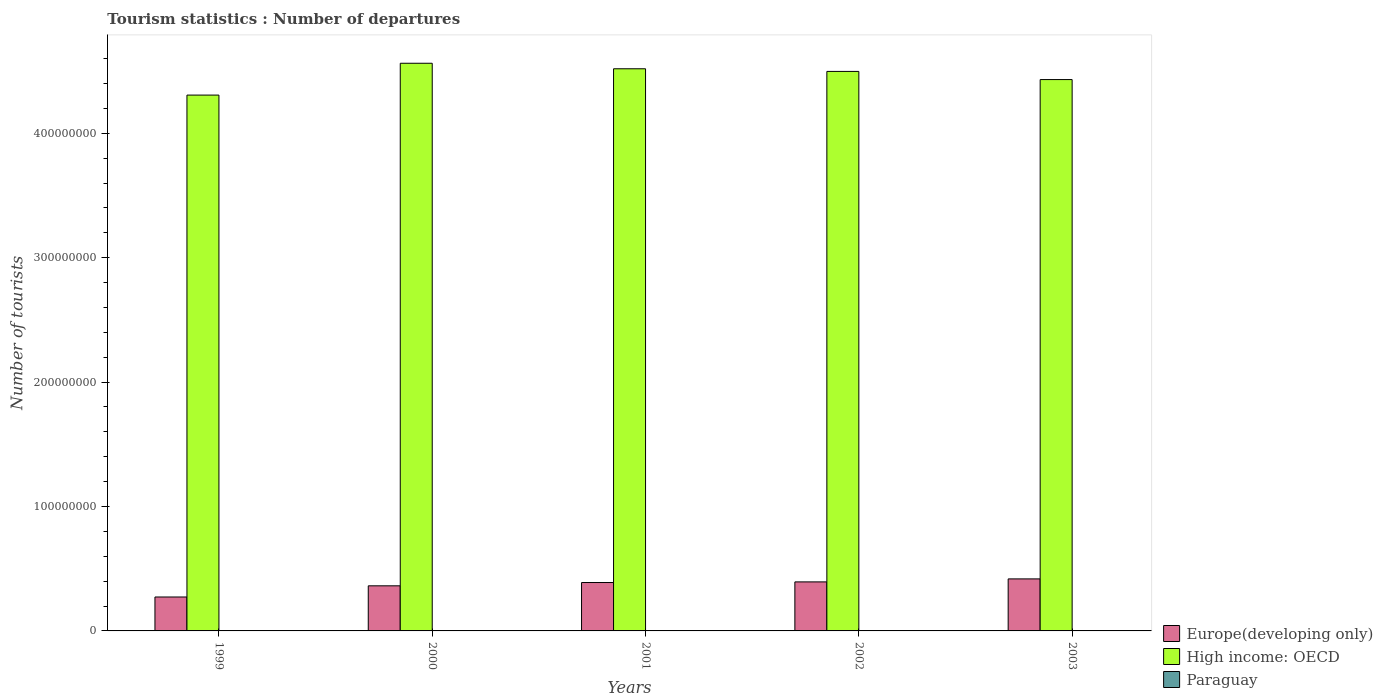Are the number of bars on each tick of the X-axis equal?
Provide a short and direct response. Yes. What is the number of tourist departures in Europe(developing only) in 2002?
Your response must be concise. 3.94e+07. Across all years, what is the maximum number of tourist departures in High income: OECD?
Offer a terse response. 4.56e+08. Across all years, what is the minimum number of tourist departures in High income: OECD?
Offer a very short reply. 4.31e+08. What is the total number of tourist departures in High income: OECD in the graph?
Offer a very short reply. 2.23e+09. What is the difference between the number of tourist departures in Paraguay in 2000 and that in 2002?
Keep it short and to the point. 3.40e+04. What is the difference between the number of tourist departures in Paraguay in 2001 and the number of tourist departures in High income: OECD in 1999?
Offer a very short reply. -4.31e+08. What is the average number of tourist departures in High income: OECD per year?
Provide a short and direct response. 4.46e+08. In the year 2000, what is the difference between the number of tourist departures in Paraguay and number of tourist departures in High income: OECD?
Offer a very short reply. -4.56e+08. In how many years, is the number of tourist departures in Paraguay greater than 380000000?
Your answer should be very brief. 0. What is the ratio of the number of tourist departures in High income: OECD in 2002 to that in 2003?
Provide a succinct answer. 1.01. Is the number of tourist departures in Paraguay in 2002 less than that in 2003?
Your response must be concise. Yes. Is the difference between the number of tourist departures in Paraguay in 2000 and 2002 greater than the difference between the number of tourist departures in High income: OECD in 2000 and 2002?
Provide a short and direct response. No. What is the difference between the highest and the second highest number of tourist departures in Paraguay?
Offer a terse response. 1.06e+05. What is the difference between the highest and the lowest number of tourist departures in High income: OECD?
Your answer should be compact. 2.56e+07. In how many years, is the number of tourist departures in High income: OECD greater than the average number of tourist departures in High income: OECD taken over all years?
Make the answer very short. 3. Is the sum of the number of tourist departures in Paraguay in 2000 and 2001 greater than the maximum number of tourist departures in Europe(developing only) across all years?
Give a very brief answer. No. What does the 1st bar from the left in 2000 represents?
Make the answer very short. Europe(developing only). What does the 3rd bar from the right in 1999 represents?
Your answer should be very brief. Europe(developing only). How many years are there in the graph?
Provide a succinct answer. 5. Are the values on the major ticks of Y-axis written in scientific E-notation?
Your answer should be very brief. No. Does the graph contain any zero values?
Offer a very short reply. No. Where does the legend appear in the graph?
Provide a short and direct response. Bottom right. What is the title of the graph?
Give a very brief answer. Tourism statistics : Number of departures. What is the label or title of the X-axis?
Provide a short and direct response. Years. What is the label or title of the Y-axis?
Provide a short and direct response. Number of tourists. What is the Number of tourists in Europe(developing only) in 1999?
Offer a very short reply. 2.73e+07. What is the Number of tourists of High income: OECD in 1999?
Make the answer very short. 4.31e+08. What is the Number of tourists of Paraguay in 1999?
Keep it short and to the point. 2.81e+05. What is the Number of tourists in Europe(developing only) in 2000?
Ensure brevity in your answer.  3.63e+07. What is the Number of tourists of High income: OECD in 2000?
Your response must be concise. 4.56e+08. What is the Number of tourists in Paraguay in 2000?
Keep it short and to the point. 1.75e+05. What is the Number of tourists in Europe(developing only) in 2001?
Your answer should be very brief. 3.89e+07. What is the Number of tourists of High income: OECD in 2001?
Your response must be concise. 4.52e+08. What is the Number of tourists in Paraguay in 2001?
Ensure brevity in your answer.  1.57e+05. What is the Number of tourists of Europe(developing only) in 2002?
Your answer should be very brief. 3.94e+07. What is the Number of tourists of High income: OECD in 2002?
Keep it short and to the point. 4.50e+08. What is the Number of tourists in Paraguay in 2002?
Give a very brief answer. 1.41e+05. What is the Number of tourists in Europe(developing only) in 2003?
Provide a succinct answer. 4.18e+07. What is the Number of tourists of High income: OECD in 2003?
Make the answer very short. 4.43e+08. What is the Number of tourists of Paraguay in 2003?
Make the answer very short. 1.53e+05. Across all years, what is the maximum Number of tourists of Europe(developing only)?
Ensure brevity in your answer.  4.18e+07. Across all years, what is the maximum Number of tourists in High income: OECD?
Provide a short and direct response. 4.56e+08. Across all years, what is the maximum Number of tourists in Paraguay?
Your answer should be very brief. 2.81e+05. Across all years, what is the minimum Number of tourists in Europe(developing only)?
Keep it short and to the point. 2.73e+07. Across all years, what is the minimum Number of tourists of High income: OECD?
Keep it short and to the point. 4.31e+08. Across all years, what is the minimum Number of tourists of Paraguay?
Make the answer very short. 1.41e+05. What is the total Number of tourists of Europe(developing only) in the graph?
Offer a terse response. 1.84e+08. What is the total Number of tourists in High income: OECD in the graph?
Offer a very short reply. 2.23e+09. What is the total Number of tourists of Paraguay in the graph?
Give a very brief answer. 9.07e+05. What is the difference between the Number of tourists of Europe(developing only) in 1999 and that in 2000?
Make the answer very short. -8.98e+06. What is the difference between the Number of tourists of High income: OECD in 1999 and that in 2000?
Keep it short and to the point. -2.56e+07. What is the difference between the Number of tourists of Paraguay in 1999 and that in 2000?
Offer a terse response. 1.06e+05. What is the difference between the Number of tourists of Europe(developing only) in 1999 and that in 2001?
Provide a short and direct response. -1.16e+07. What is the difference between the Number of tourists of High income: OECD in 1999 and that in 2001?
Your response must be concise. -2.11e+07. What is the difference between the Number of tourists in Paraguay in 1999 and that in 2001?
Provide a short and direct response. 1.24e+05. What is the difference between the Number of tourists of Europe(developing only) in 1999 and that in 2002?
Offer a very short reply. -1.21e+07. What is the difference between the Number of tourists in High income: OECD in 1999 and that in 2002?
Your answer should be very brief. -1.90e+07. What is the difference between the Number of tourists in Paraguay in 1999 and that in 2002?
Make the answer very short. 1.40e+05. What is the difference between the Number of tourists of Europe(developing only) in 1999 and that in 2003?
Give a very brief answer. -1.45e+07. What is the difference between the Number of tourists in High income: OECD in 1999 and that in 2003?
Ensure brevity in your answer.  -1.25e+07. What is the difference between the Number of tourists of Paraguay in 1999 and that in 2003?
Keep it short and to the point. 1.28e+05. What is the difference between the Number of tourists of Europe(developing only) in 2000 and that in 2001?
Give a very brief answer. -2.65e+06. What is the difference between the Number of tourists of High income: OECD in 2000 and that in 2001?
Offer a very short reply. 4.44e+06. What is the difference between the Number of tourists of Paraguay in 2000 and that in 2001?
Your response must be concise. 1.80e+04. What is the difference between the Number of tourists of Europe(developing only) in 2000 and that in 2002?
Ensure brevity in your answer.  -3.16e+06. What is the difference between the Number of tourists in High income: OECD in 2000 and that in 2002?
Provide a short and direct response. 6.56e+06. What is the difference between the Number of tourists in Paraguay in 2000 and that in 2002?
Offer a very short reply. 3.40e+04. What is the difference between the Number of tourists in Europe(developing only) in 2000 and that in 2003?
Keep it short and to the point. -5.57e+06. What is the difference between the Number of tourists of High income: OECD in 2000 and that in 2003?
Ensure brevity in your answer.  1.31e+07. What is the difference between the Number of tourists in Paraguay in 2000 and that in 2003?
Offer a very short reply. 2.20e+04. What is the difference between the Number of tourists of Europe(developing only) in 2001 and that in 2002?
Offer a terse response. -5.12e+05. What is the difference between the Number of tourists in High income: OECD in 2001 and that in 2002?
Provide a succinct answer. 2.12e+06. What is the difference between the Number of tourists in Paraguay in 2001 and that in 2002?
Keep it short and to the point. 1.60e+04. What is the difference between the Number of tourists of Europe(developing only) in 2001 and that in 2003?
Give a very brief answer. -2.92e+06. What is the difference between the Number of tourists in High income: OECD in 2001 and that in 2003?
Keep it short and to the point. 8.67e+06. What is the difference between the Number of tourists of Paraguay in 2001 and that in 2003?
Your answer should be very brief. 4000. What is the difference between the Number of tourists in Europe(developing only) in 2002 and that in 2003?
Your response must be concise. -2.41e+06. What is the difference between the Number of tourists of High income: OECD in 2002 and that in 2003?
Offer a terse response. 6.55e+06. What is the difference between the Number of tourists of Paraguay in 2002 and that in 2003?
Provide a short and direct response. -1.20e+04. What is the difference between the Number of tourists in Europe(developing only) in 1999 and the Number of tourists in High income: OECD in 2000?
Provide a short and direct response. -4.29e+08. What is the difference between the Number of tourists in Europe(developing only) in 1999 and the Number of tourists in Paraguay in 2000?
Make the answer very short. 2.71e+07. What is the difference between the Number of tourists of High income: OECD in 1999 and the Number of tourists of Paraguay in 2000?
Make the answer very short. 4.31e+08. What is the difference between the Number of tourists in Europe(developing only) in 1999 and the Number of tourists in High income: OECD in 2001?
Offer a very short reply. -4.25e+08. What is the difference between the Number of tourists of Europe(developing only) in 1999 and the Number of tourists of Paraguay in 2001?
Make the answer very short. 2.71e+07. What is the difference between the Number of tourists in High income: OECD in 1999 and the Number of tourists in Paraguay in 2001?
Your answer should be very brief. 4.31e+08. What is the difference between the Number of tourists of Europe(developing only) in 1999 and the Number of tourists of High income: OECD in 2002?
Your response must be concise. -4.22e+08. What is the difference between the Number of tourists in Europe(developing only) in 1999 and the Number of tourists in Paraguay in 2002?
Your response must be concise. 2.71e+07. What is the difference between the Number of tourists in High income: OECD in 1999 and the Number of tourists in Paraguay in 2002?
Give a very brief answer. 4.31e+08. What is the difference between the Number of tourists in Europe(developing only) in 1999 and the Number of tourists in High income: OECD in 2003?
Keep it short and to the point. -4.16e+08. What is the difference between the Number of tourists in Europe(developing only) in 1999 and the Number of tourists in Paraguay in 2003?
Your response must be concise. 2.71e+07. What is the difference between the Number of tourists of High income: OECD in 1999 and the Number of tourists of Paraguay in 2003?
Your answer should be compact. 4.31e+08. What is the difference between the Number of tourists in Europe(developing only) in 2000 and the Number of tourists in High income: OECD in 2001?
Your answer should be compact. -4.16e+08. What is the difference between the Number of tourists of Europe(developing only) in 2000 and the Number of tourists of Paraguay in 2001?
Offer a terse response. 3.61e+07. What is the difference between the Number of tourists of High income: OECD in 2000 and the Number of tourists of Paraguay in 2001?
Give a very brief answer. 4.56e+08. What is the difference between the Number of tourists in Europe(developing only) in 2000 and the Number of tourists in High income: OECD in 2002?
Make the answer very short. -4.13e+08. What is the difference between the Number of tourists of Europe(developing only) in 2000 and the Number of tourists of Paraguay in 2002?
Give a very brief answer. 3.61e+07. What is the difference between the Number of tourists in High income: OECD in 2000 and the Number of tourists in Paraguay in 2002?
Provide a short and direct response. 4.56e+08. What is the difference between the Number of tourists of Europe(developing only) in 2000 and the Number of tourists of High income: OECD in 2003?
Offer a very short reply. -4.07e+08. What is the difference between the Number of tourists of Europe(developing only) in 2000 and the Number of tourists of Paraguay in 2003?
Give a very brief answer. 3.61e+07. What is the difference between the Number of tourists of High income: OECD in 2000 and the Number of tourists of Paraguay in 2003?
Offer a very short reply. 4.56e+08. What is the difference between the Number of tourists in Europe(developing only) in 2001 and the Number of tourists in High income: OECD in 2002?
Offer a terse response. -4.11e+08. What is the difference between the Number of tourists of Europe(developing only) in 2001 and the Number of tourists of Paraguay in 2002?
Provide a succinct answer. 3.88e+07. What is the difference between the Number of tourists in High income: OECD in 2001 and the Number of tourists in Paraguay in 2002?
Ensure brevity in your answer.  4.52e+08. What is the difference between the Number of tourists of Europe(developing only) in 2001 and the Number of tourists of High income: OECD in 2003?
Give a very brief answer. -4.04e+08. What is the difference between the Number of tourists of Europe(developing only) in 2001 and the Number of tourists of Paraguay in 2003?
Offer a terse response. 3.87e+07. What is the difference between the Number of tourists in High income: OECD in 2001 and the Number of tourists in Paraguay in 2003?
Keep it short and to the point. 4.52e+08. What is the difference between the Number of tourists in Europe(developing only) in 2002 and the Number of tourists in High income: OECD in 2003?
Offer a terse response. -4.04e+08. What is the difference between the Number of tourists in Europe(developing only) in 2002 and the Number of tourists in Paraguay in 2003?
Offer a very short reply. 3.93e+07. What is the difference between the Number of tourists of High income: OECD in 2002 and the Number of tourists of Paraguay in 2003?
Your answer should be very brief. 4.50e+08. What is the average Number of tourists of Europe(developing only) per year?
Your answer should be compact. 3.67e+07. What is the average Number of tourists of High income: OECD per year?
Make the answer very short. 4.46e+08. What is the average Number of tourists in Paraguay per year?
Keep it short and to the point. 1.81e+05. In the year 1999, what is the difference between the Number of tourists of Europe(developing only) and Number of tourists of High income: OECD?
Offer a very short reply. -4.03e+08. In the year 1999, what is the difference between the Number of tourists in Europe(developing only) and Number of tourists in Paraguay?
Make the answer very short. 2.70e+07. In the year 1999, what is the difference between the Number of tourists in High income: OECD and Number of tourists in Paraguay?
Your answer should be very brief. 4.30e+08. In the year 2000, what is the difference between the Number of tourists of Europe(developing only) and Number of tourists of High income: OECD?
Provide a short and direct response. -4.20e+08. In the year 2000, what is the difference between the Number of tourists of Europe(developing only) and Number of tourists of Paraguay?
Provide a succinct answer. 3.61e+07. In the year 2000, what is the difference between the Number of tourists in High income: OECD and Number of tourists in Paraguay?
Provide a succinct answer. 4.56e+08. In the year 2001, what is the difference between the Number of tourists of Europe(developing only) and Number of tourists of High income: OECD?
Provide a short and direct response. -4.13e+08. In the year 2001, what is the difference between the Number of tourists in Europe(developing only) and Number of tourists in Paraguay?
Make the answer very short. 3.87e+07. In the year 2001, what is the difference between the Number of tourists of High income: OECD and Number of tourists of Paraguay?
Give a very brief answer. 4.52e+08. In the year 2002, what is the difference between the Number of tourists in Europe(developing only) and Number of tourists in High income: OECD?
Provide a succinct answer. -4.10e+08. In the year 2002, what is the difference between the Number of tourists in Europe(developing only) and Number of tourists in Paraguay?
Your answer should be very brief. 3.93e+07. In the year 2002, what is the difference between the Number of tourists of High income: OECD and Number of tourists of Paraguay?
Your answer should be compact. 4.50e+08. In the year 2003, what is the difference between the Number of tourists in Europe(developing only) and Number of tourists in High income: OECD?
Provide a short and direct response. -4.01e+08. In the year 2003, what is the difference between the Number of tourists in Europe(developing only) and Number of tourists in Paraguay?
Keep it short and to the point. 4.17e+07. In the year 2003, what is the difference between the Number of tourists in High income: OECD and Number of tourists in Paraguay?
Make the answer very short. 4.43e+08. What is the ratio of the Number of tourists of Europe(developing only) in 1999 to that in 2000?
Your answer should be very brief. 0.75. What is the ratio of the Number of tourists of High income: OECD in 1999 to that in 2000?
Offer a very short reply. 0.94. What is the ratio of the Number of tourists of Paraguay in 1999 to that in 2000?
Your answer should be very brief. 1.61. What is the ratio of the Number of tourists in Europe(developing only) in 1999 to that in 2001?
Make the answer very short. 0.7. What is the ratio of the Number of tourists of High income: OECD in 1999 to that in 2001?
Offer a terse response. 0.95. What is the ratio of the Number of tourists in Paraguay in 1999 to that in 2001?
Give a very brief answer. 1.79. What is the ratio of the Number of tourists in Europe(developing only) in 1999 to that in 2002?
Your answer should be very brief. 0.69. What is the ratio of the Number of tourists of High income: OECD in 1999 to that in 2002?
Keep it short and to the point. 0.96. What is the ratio of the Number of tourists in Paraguay in 1999 to that in 2002?
Make the answer very short. 1.99. What is the ratio of the Number of tourists in Europe(developing only) in 1999 to that in 2003?
Keep it short and to the point. 0.65. What is the ratio of the Number of tourists of High income: OECD in 1999 to that in 2003?
Ensure brevity in your answer.  0.97. What is the ratio of the Number of tourists in Paraguay in 1999 to that in 2003?
Keep it short and to the point. 1.84. What is the ratio of the Number of tourists in Europe(developing only) in 2000 to that in 2001?
Your answer should be very brief. 0.93. What is the ratio of the Number of tourists of High income: OECD in 2000 to that in 2001?
Your answer should be compact. 1.01. What is the ratio of the Number of tourists in Paraguay in 2000 to that in 2001?
Offer a terse response. 1.11. What is the ratio of the Number of tourists of Europe(developing only) in 2000 to that in 2002?
Provide a succinct answer. 0.92. What is the ratio of the Number of tourists in High income: OECD in 2000 to that in 2002?
Your answer should be compact. 1.01. What is the ratio of the Number of tourists in Paraguay in 2000 to that in 2002?
Provide a succinct answer. 1.24. What is the ratio of the Number of tourists of Europe(developing only) in 2000 to that in 2003?
Your answer should be compact. 0.87. What is the ratio of the Number of tourists of High income: OECD in 2000 to that in 2003?
Give a very brief answer. 1.03. What is the ratio of the Number of tourists of Paraguay in 2000 to that in 2003?
Your answer should be very brief. 1.14. What is the ratio of the Number of tourists in Paraguay in 2001 to that in 2002?
Your response must be concise. 1.11. What is the ratio of the Number of tourists of Europe(developing only) in 2001 to that in 2003?
Your answer should be compact. 0.93. What is the ratio of the Number of tourists in High income: OECD in 2001 to that in 2003?
Offer a terse response. 1.02. What is the ratio of the Number of tourists in Paraguay in 2001 to that in 2003?
Your answer should be very brief. 1.03. What is the ratio of the Number of tourists of Europe(developing only) in 2002 to that in 2003?
Your answer should be compact. 0.94. What is the ratio of the Number of tourists of High income: OECD in 2002 to that in 2003?
Provide a succinct answer. 1.01. What is the ratio of the Number of tourists in Paraguay in 2002 to that in 2003?
Give a very brief answer. 0.92. What is the difference between the highest and the second highest Number of tourists of Europe(developing only)?
Offer a very short reply. 2.41e+06. What is the difference between the highest and the second highest Number of tourists of High income: OECD?
Your response must be concise. 4.44e+06. What is the difference between the highest and the second highest Number of tourists of Paraguay?
Ensure brevity in your answer.  1.06e+05. What is the difference between the highest and the lowest Number of tourists in Europe(developing only)?
Offer a terse response. 1.45e+07. What is the difference between the highest and the lowest Number of tourists in High income: OECD?
Ensure brevity in your answer.  2.56e+07. 